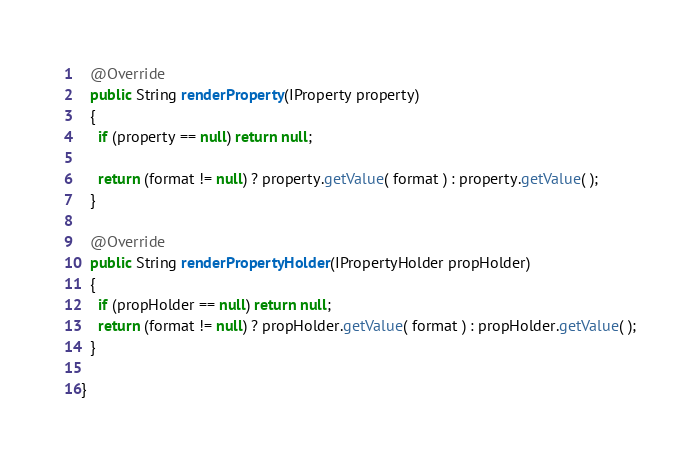Convert code to text. <code><loc_0><loc_0><loc_500><loc_500><_Java_>  @Override
  public String renderProperty(IProperty property)
  {
    if (property == null) return null;
		
    return (format != null) ? property.getValue( format ) : property.getValue( );
  }

  @Override
  public String renderPropertyHolder(IPropertyHolder propHolder)
  {
    if (propHolder == null) return null;
    return (format != null) ? propHolder.getValue( format ) : propHolder.getValue( );
  }

}
</code> 